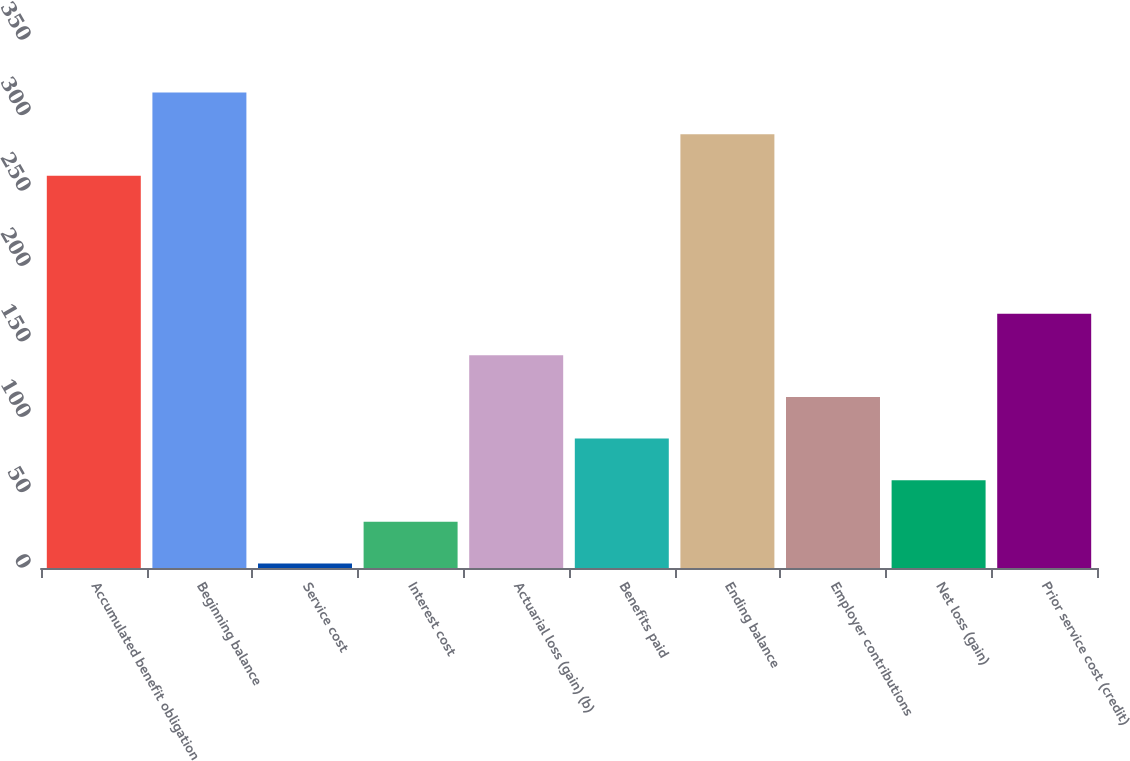Convert chart. <chart><loc_0><loc_0><loc_500><loc_500><bar_chart><fcel>Accumulated benefit obligation<fcel>Beginning balance<fcel>Service cost<fcel>Interest cost<fcel>Actuarial loss (gain) (b)<fcel>Benefits paid<fcel>Ending balance<fcel>Employer contributions<fcel>Net loss (gain)<fcel>Prior service cost (credit)<nl><fcel>260<fcel>315.2<fcel>3<fcel>30.6<fcel>141<fcel>85.8<fcel>287.6<fcel>113.4<fcel>58.2<fcel>168.6<nl></chart> 